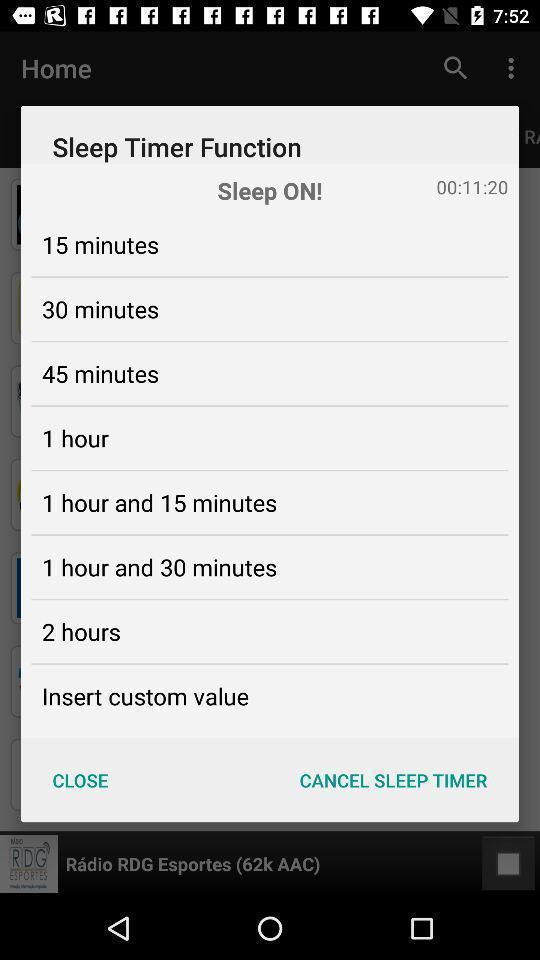Explain the elements present in this screenshot. Pop-up message with different timings to set for sleeping. 